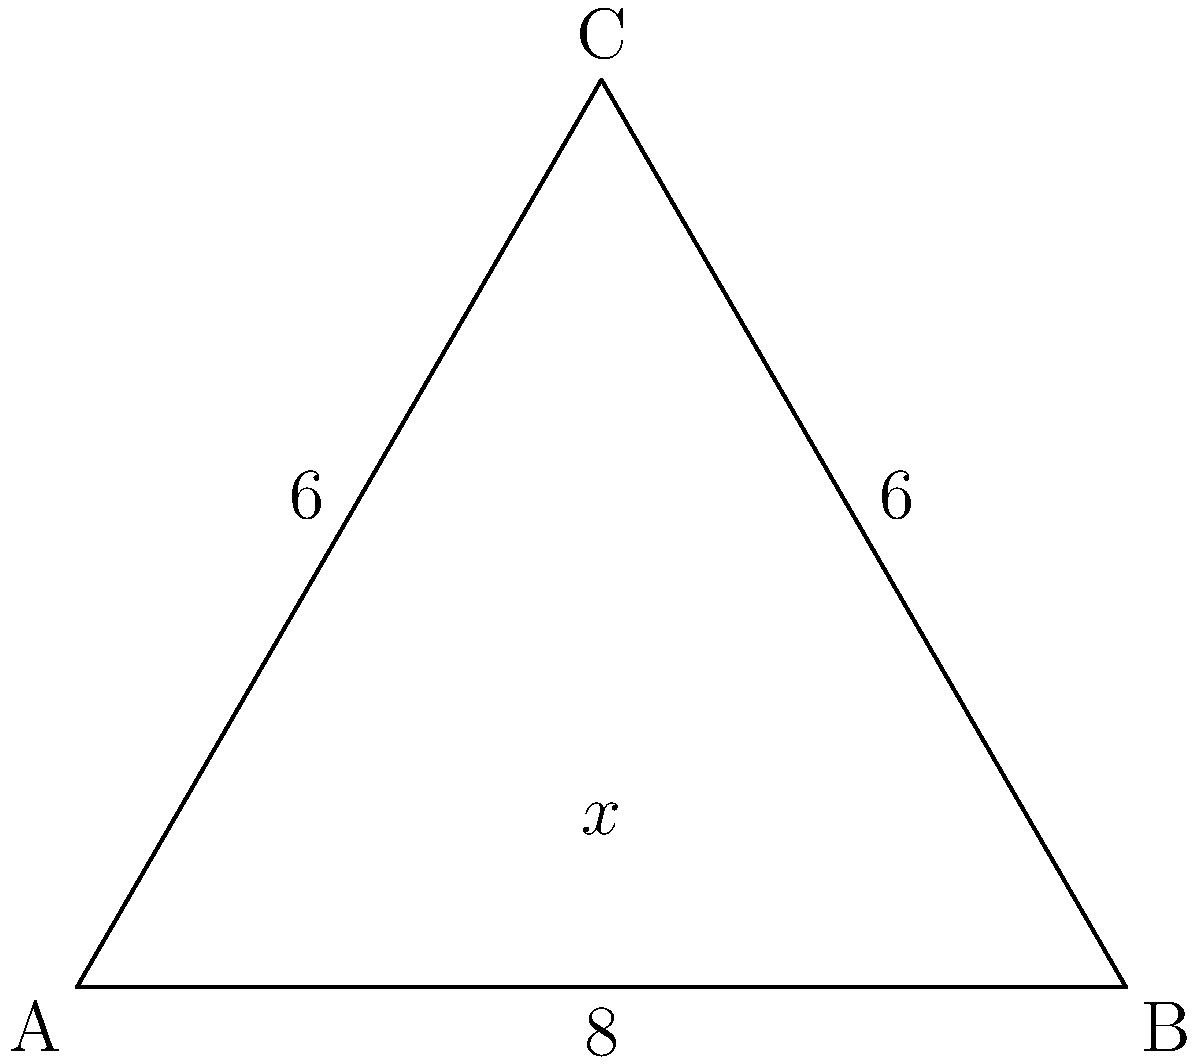Hey Mandy, remember that geometry problem we used to discuss during our coffee breaks? I found a similar one that reminded me of our conversations. In this isosceles triangle ABC, AC = BC = 6 units, and AB = 8 units. Can you help me find the measure of angle x at the base of the triangle? Let's approach this step-by-step, just like we used to do:

1) First, recall that in an isosceles triangle, the angles opposite the equal sides are also equal. So, if AC = BC, then angle A = angle B.

2) We know that the sum of angles in a triangle is always 180°. Let's call the measure of angle C as y°. Then:

   $x° + x° + y° = 180°$
   $2x° + y° = 180°$

3) Now, we can use the cosine law to find cos(y):
   $\cos(y) = \frac{AC^2 + BC^2 - AB^2}{2(AC)(BC)}$
   
   $\cos(y) = \frac{6^2 + 6^2 - 8^2}{2(6)(6)} = \frac{72 - 64}{72} = \frac{1}{9}$

4) We can find y using the inverse cosine function:
   $y = \arccos(\frac{1}{9}) \approx 83.62°$

5) Now we can substitute this back into our equation from step 2:
   $2x° + 83.62° = 180°$
   $2x° = 96.38°$
   $x° = 48.19°$

Therefore, the measure of angle x is approximately 48.19°.
Answer: $48.19°$ 